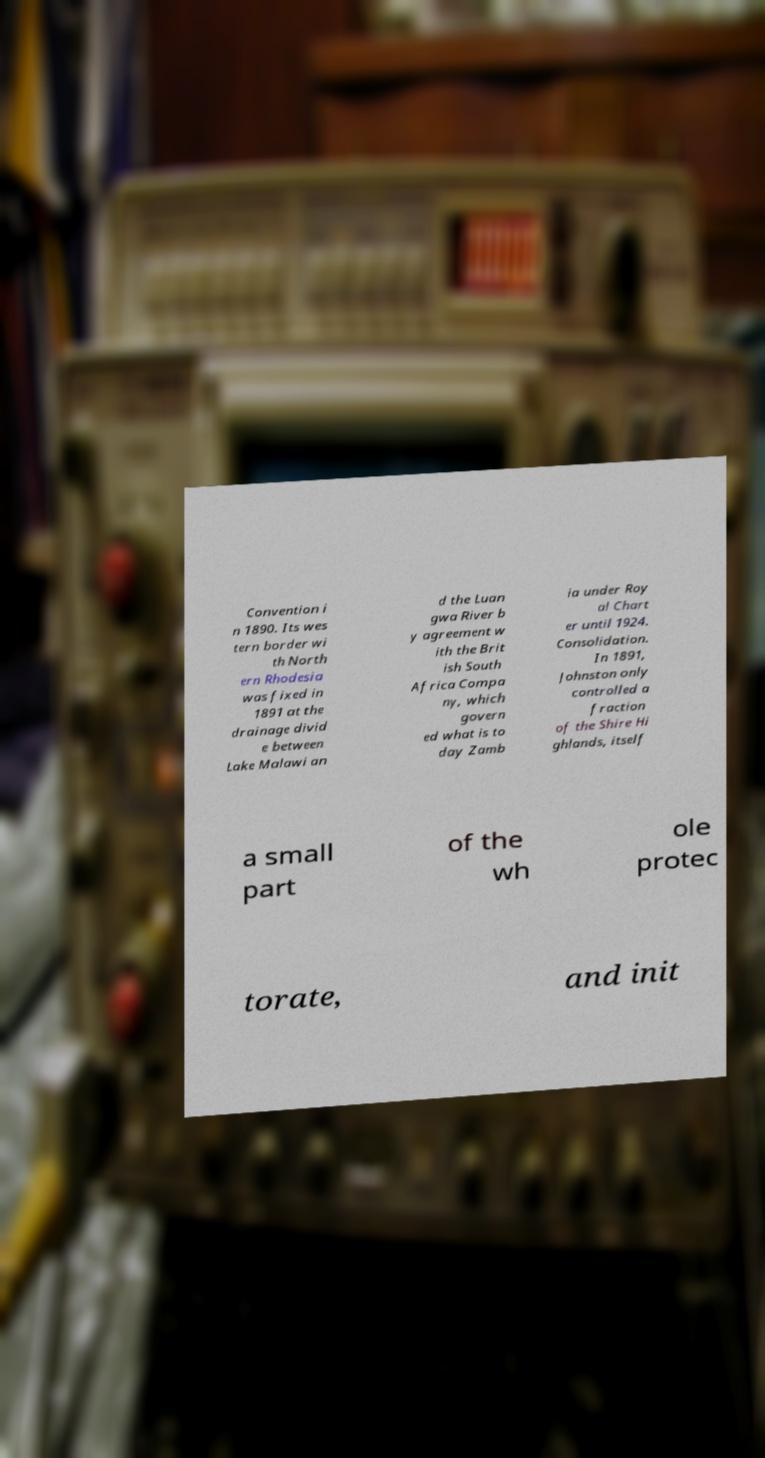I need the written content from this picture converted into text. Can you do that? Convention i n 1890. Its wes tern border wi th North ern Rhodesia was fixed in 1891 at the drainage divid e between Lake Malawi an d the Luan gwa River b y agreement w ith the Brit ish South Africa Compa ny, which govern ed what is to day Zamb ia under Roy al Chart er until 1924. Consolidation. In 1891, Johnston only controlled a fraction of the Shire Hi ghlands, itself a small part of the wh ole protec torate, and init 